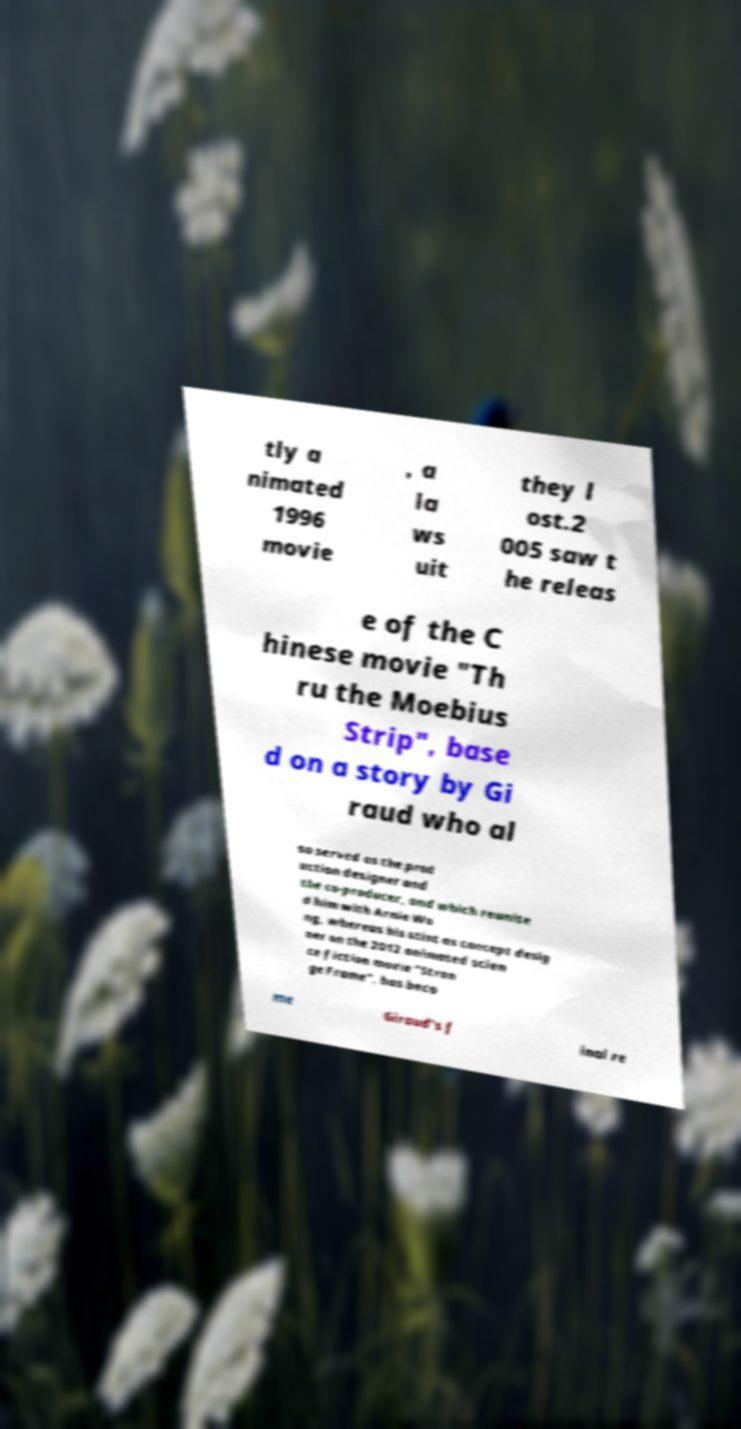For documentation purposes, I need the text within this image transcribed. Could you provide that? tly a nimated 1996 movie , a la ws uit they l ost.2 005 saw t he releas e of the C hinese movie "Th ru the Moebius Strip", base d on a story by Gi raud who al so served as the prod uction designer and the co-producer, and which reunite d him with Arnie Wo ng, whereas his stint as concept desig ner on the 2012 animated scien ce fiction movie "Stran ge Frame", has beco me Giraud's f inal re 